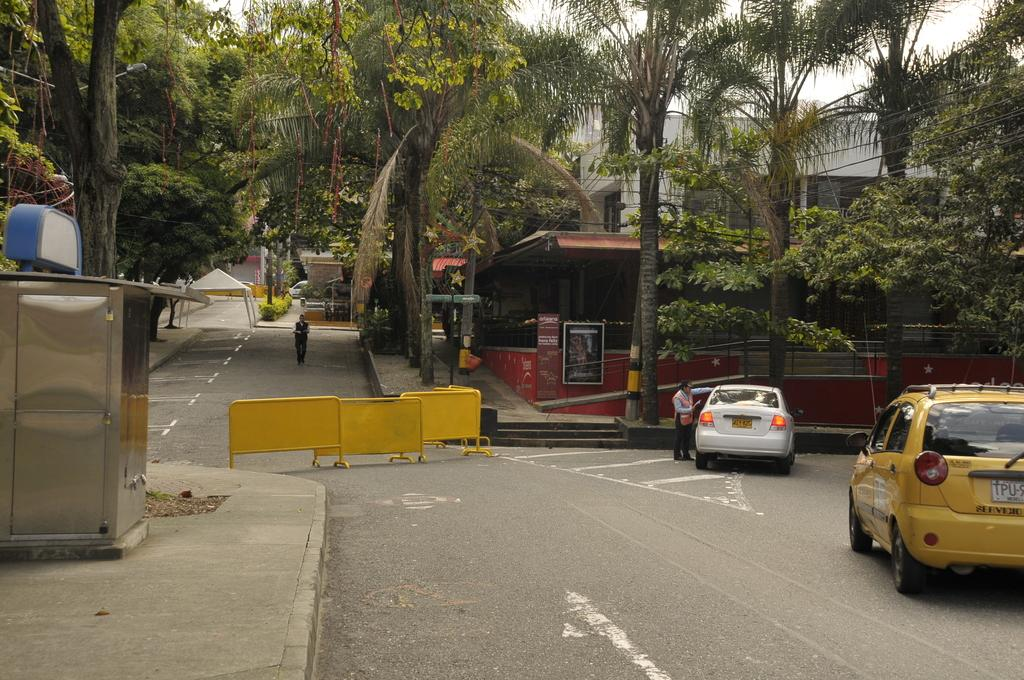What type of vehicles can be seen in the image? There are cars in the image. What type of structures are present in the image? There are houses in the image. Can you identify any living beings in the image? Yes, there is a person in the image. What type of natural elements can be seen in the image? There are trees and plants in the image. What is visible in the background of the image? The sky is visible in the image. How many jellyfish can be seen swimming in the image? There are no jellyfish present in the image; it does not depict a water environment. What body part of the person in the image is visible? The provided facts do not specify any body parts of the person visible in the image. 